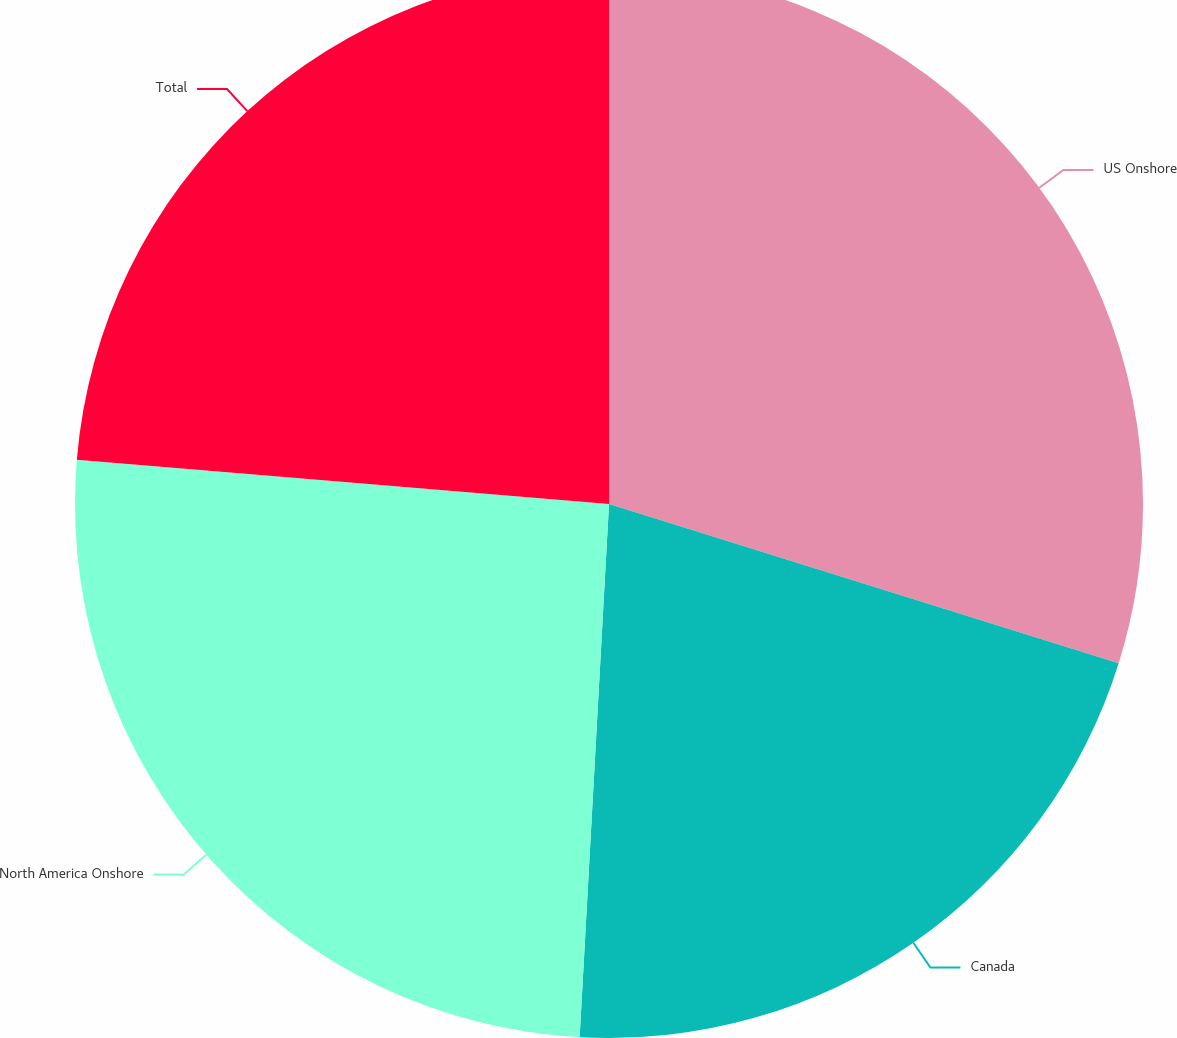Convert chart. <chart><loc_0><loc_0><loc_500><loc_500><pie_chart><fcel>US Onshore<fcel>Canada<fcel>North America Onshore<fcel>Total<nl><fcel>29.82%<fcel>21.05%<fcel>25.44%<fcel>23.68%<nl></chart> 